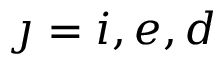Convert formula to latex. <formula><loc_0><loc_0><loc_500><loc_500>\jmath = i , e , d</formula> 